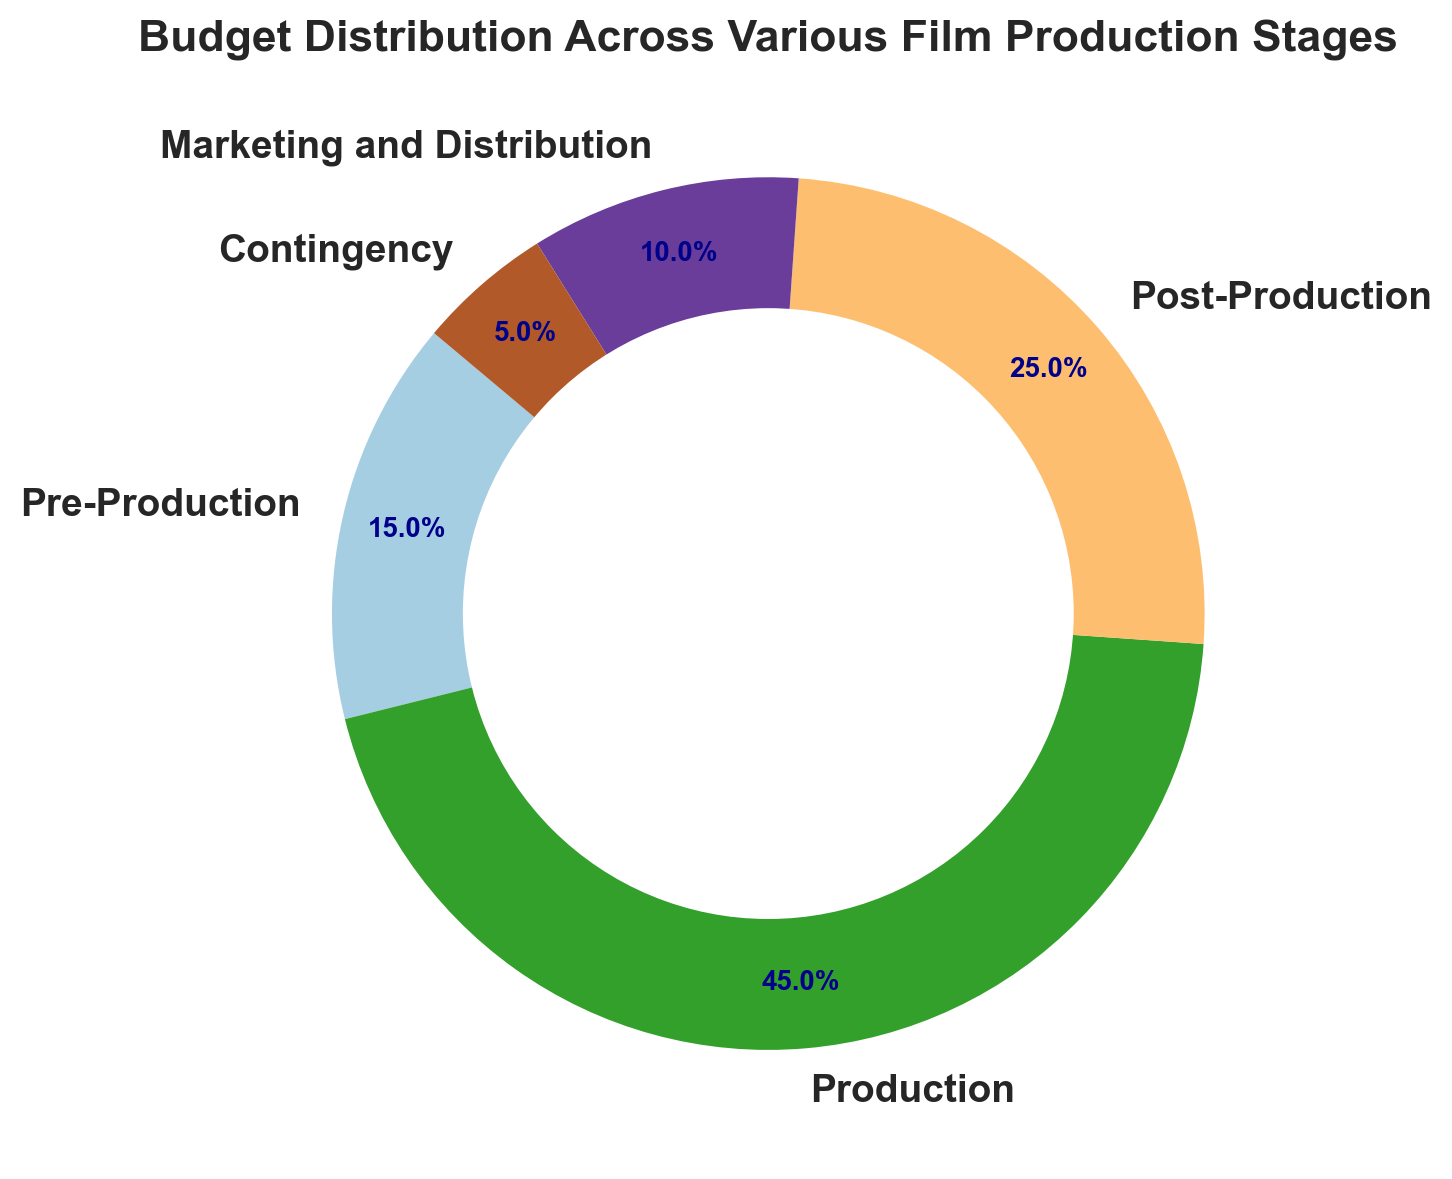What is the percentage allocation for the Production stage? The Production stage is one of the segments labeled on the chart. From the figure, the Production stage segment has a percentage value labeled directly on the chart.
Answer: 45% How much more budget percentage is allocated to Production compared to Pre-Production? The Production stage has 45% and the Pre-Production stage has 15%. To find the difference, subtract the Pre-Production percentage from the Production percentage: 45% - 15% = 30%.
Answer: 30% What is the total budget percentage allocated to Production and Post-Production combined? The Production stage has 45% and the Post-Production stage has 25%. To find the total budget percentage of these two stages combined, add their percentages: 45% + 25% = 70%.
Answer: 70% Which stage receives the smallest portion of the budget? Looking at the different segments of the ring chart, the Contingency stage has the smallest percentage value of 5%.
Answer: Contingency What is the combined percentage of budget allocated to Marketing and Distribution, and Contingency? The Marketing and Distribution stage has 10% and the Contingency stage has 5%. To find their combined total, add the percentages: 10% + 5% = 15%.
Answer: 15% Which stages combined make up half of the budget allocation? Half of the budget is 50%. The Production stage alone has 45%, so adding the next largest stage to reach close to 50% is necessary. The Post-Production stage is the next largest with 25%. However, adding Production (45%) and Pre-Production (15%) gives exactly 60%, so we must adjust. Thus, with Precision: Production (45%) and a smaller stage like Marketing and Distribution (10%) combined reach 55%, slightly more simple as no exact half-combination perfectly at 50%.
Answer: Production and Marketing and Distribution Which stage is allocated more budget, Post-Production or Marketing and Distribution? The Post-Production stage has a larger visual segment with a percentage value of 25%, while the Marketing and Distribution stage has a smaller segment with 10%.
Answer: Post-Production How many stages have a budget allocation greater than 20%? From the chart, two stages have budget percentages greater than 20%: Production (45%) and Post-Production (25%).
Answer: 2 Are Pre-Production and Contingency stages combined less than the Production stage in terms of budget allocation? The Pre-Production stage has 15% and Contingency has 5%. Combined, their total is 15% + 5% = 20%, which is less than the Production stage which has 45%.
Answer: Yes What is the ratio of the budget allocation between Post-Production and Contingency? The Post-Production stage has 25% and the Contingency stage has 5%. To find the ratio, divide the Post-Production percentage by the Contingency percentage: 25% / 5% = 5:1.
Answer: 5:1 